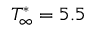<formula> <loc_0><loc_0><loc_500><loc_500>T _ { \infty } ^ { * } = 5 . 5</formula> 